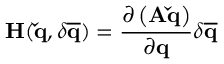Convert formula to latex. <formula><loc_0><loc_0><loc_500><loc_500>H ( \check { q } , \delta \overline { q } ) = \frac { \partial \left ( A \check { q } \right ) } { \partial q } \delta \overline { q }</formula> 